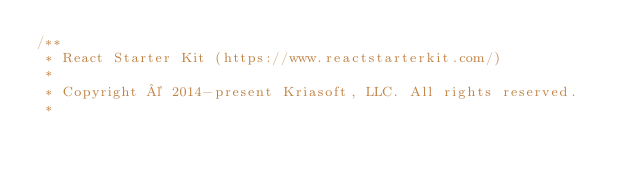Convert code to text. <code><loc_0><loc_0><loc_500><loc_500><_CSS_>/**
 * React Starter Kit (https://www.reactstarterkit.com/)
 *
 * Copyright © 2014-present Kriasoft, LLC. All rights reserved.
 *</code> 